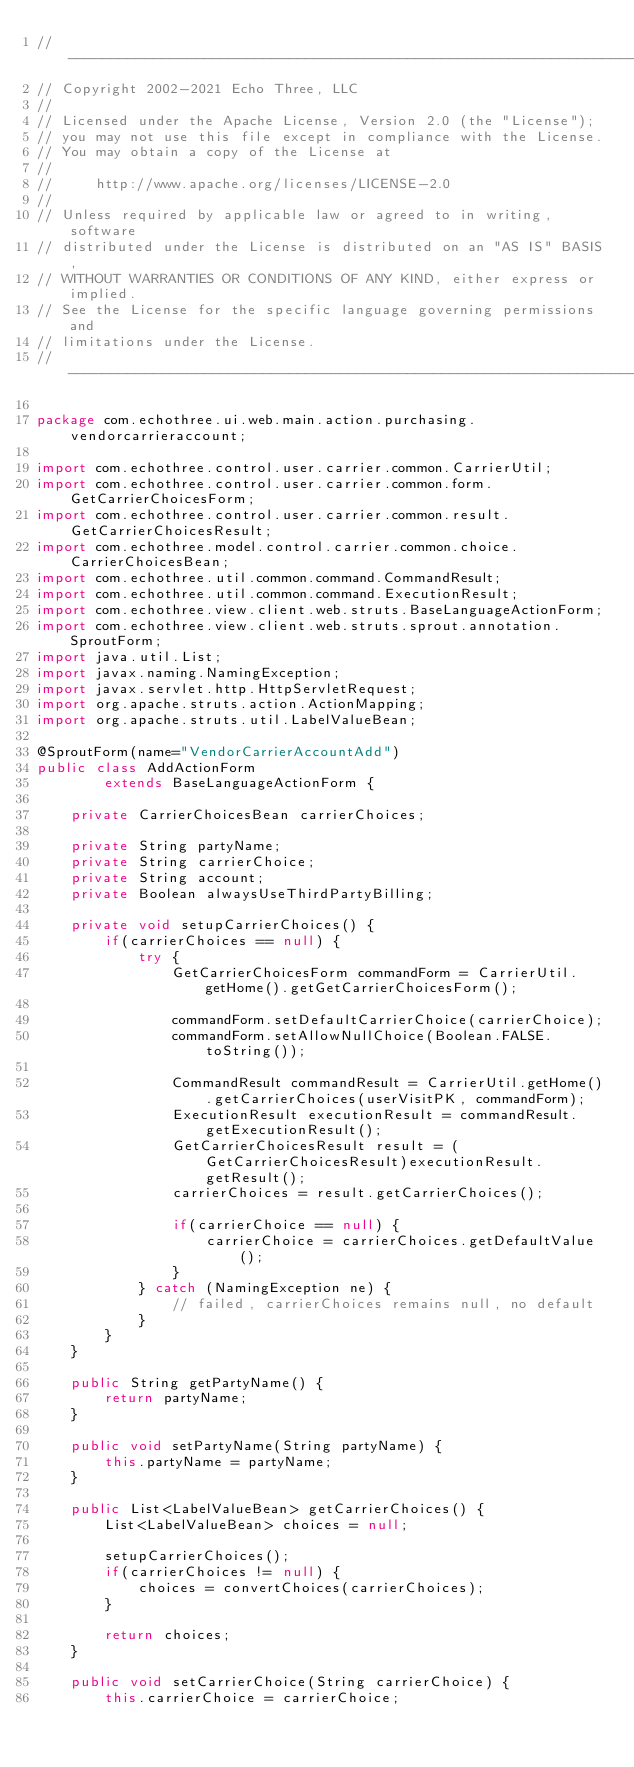<code> <loc_0><loc_0><loc_500><loc_500><_Java_>// --------------------------------------------------------------------------------
// Copyright 2002-2021 Echo Three, LLC
//
// Licensed under the Apache License, Version 2.0 (the "License");
// you may not use this file except in compliance with the License.
// You may obtain a copy of the License at
//
//     http://www.apache.org/licenses/LICENSE-2.0
//
// Unless required by applicable law or agreed to in writing, software
// distributed under the License is distributed on an "AS IS" BASIS,
// WITHOUT WARRANTIES OR CONDITIONS OF ANY KIND, either express or implied.
// See the License for the specific language governing permissions and
// limitations under the License.
// --------------------------------------------------------------------------------

package com.echothree.ui.web.main.action.purchasing.vendorcarrieraccount;

import com.echothree.control.user.carrier.common.CarrierUtil;
import com.echothree.control.user.carrier.common.form.GetCarrierChoicesForm;
import com.echothree.control.user.carrier.common.result.GetCarrierChoicesResult;
import com.echothree.model.control.carrier.common.choice.CarrierChoicesBean;
import com.echothree.util.common.command.CommandResult;
import com.echothree.util.common.command.ExecutionResult;
import com.echothree.view.client.web.struts.BaseLanguageActionForm;
import com.echothree.view.client.web.struts.sprout.annotation.SproutForm;
import java.util.List;
import javax.naming.NamingException;
import javax.servlet.http.HttpServletRequest;
import org.apache.struts.action.ActionMapping;
import org.apache.struts.util.LabelValueBean;

@SproutForm(name="VendorCarrierAccountAdd")
public class AddActionForm
        extends BaseLanguageActionForm {

    private CarrierChoicesBean carrierChoices;

    private String partyName;
    private String carrierChoice;
    private String account;
    private Boolean alwaysUseThirdPartyBilling;

    private void setupCarrierChoices() {
        if(carrierChoices == null) {
            try {
                GetCarrierChoicesForm commandForm = CarrierUtil.getHome().getGetCarrierChoicesForm();

                commandForm.setDefaultCarrierChoice(carrierChoice);
                commandForm.setAllowNullChoice(Boolean.FALSE.toString());

                CommandResult commandResult = CarrierUtil.getHome().getCarrierChoices(userVisitPK, commandForm);
                ExecutionResult executionResult = commandResult.getExecutionResult();
                GetCarrierChoicesResult result = (GetCarrierChoicesResult)executionResult.getResult();
                carrierChoices = result.getCarrierChoices();

                if(carrierChoice == null) {
                    carrierChoice = carrierChoices.getDefaultValue();
                }
            } catch (NamingException ne) {
                // failed, carrierChoices remains null, no default
            }
        }
    }

    public String getPartyName() {
        return partyName;
    }

    public void setPartyName(String partyName) {
        this.partyName = partyName;
    }

    public List<LabelValueBean> getCarrierChoices() {
        List<LabelValueBean> choices = null;

        setupCarrierChoices();
        if(carrierChoices != null) {
            choices = convertChoices(carrierChoices);
        }

        return choices;
    }

    public void setCarrierChoice(String carrierChoice) {
        this.carrierChoice = carrierChoice;</code> 